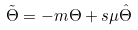<formula> <loc_0><loc_0><loc_500><loc_500>\tilde { \Theta } = - m \Theta + s \mu \hat { \Theta }</formula> 